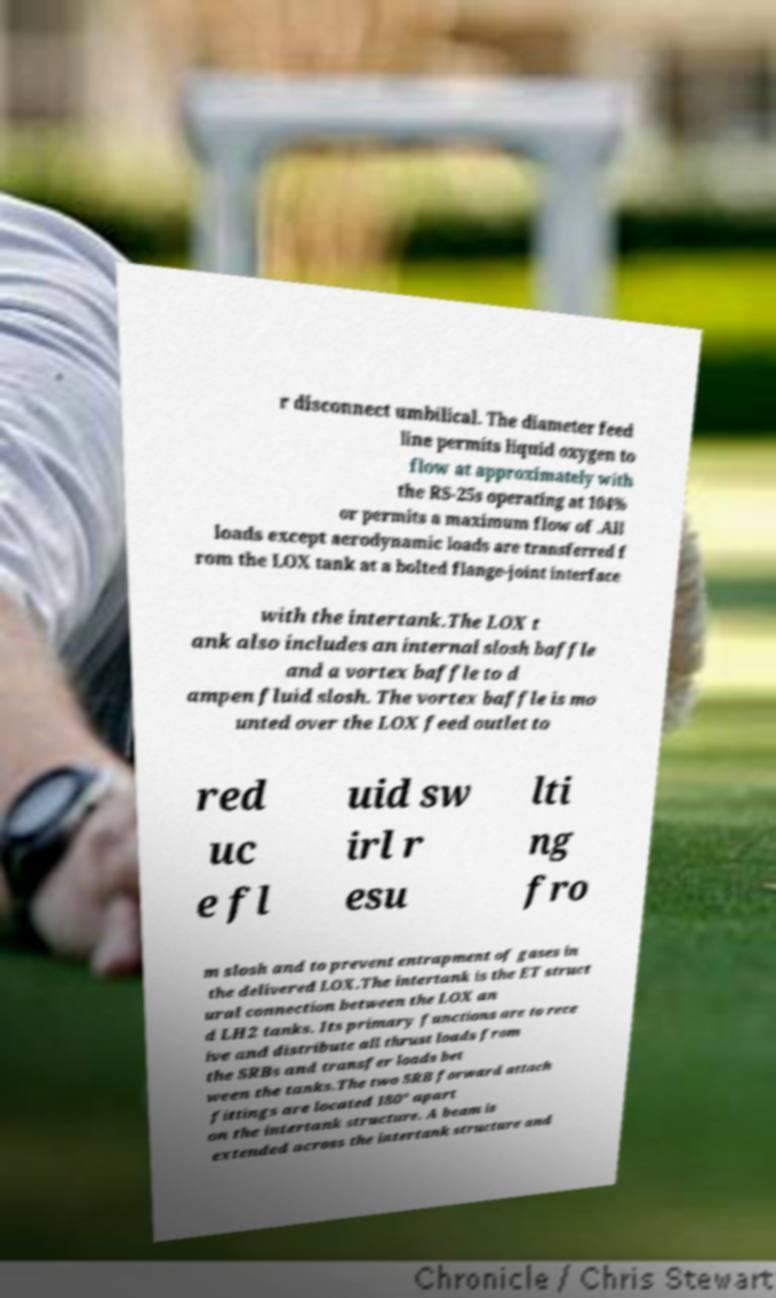For documentation purposes, I need the text within this image transcribed. Could you provide that? r disconnect umbilical. The diameter feed line permits liquid oxygen to flow at approximately with the RS-25s operating at 104% or permits a maximum flow of .All loads except aerodynamic loads are transferred f rom the LOX tank at a bolted flange-joint interface with the intertank.The LOX t ank also includes an internal slosh baffle and a vortex baffle to d ampen fluid slosh. The vortex baffle is mo unted over the LOX feed outlet to red uc e fl uid sw irl r esu lti ng fro m slosh and to prevent entrapment of gases in the delivered LOX.The intertank is the ET struct ural connection between the LOX an d LH2 tanks. Its primary functions are to rece ive and distribute all thrust loads from the SRBs and transfer loads bet ween the tanks.The two SRB forward attach fittings are located 180° apart on the intertank structure. A beam is extended across the intertank structure and 